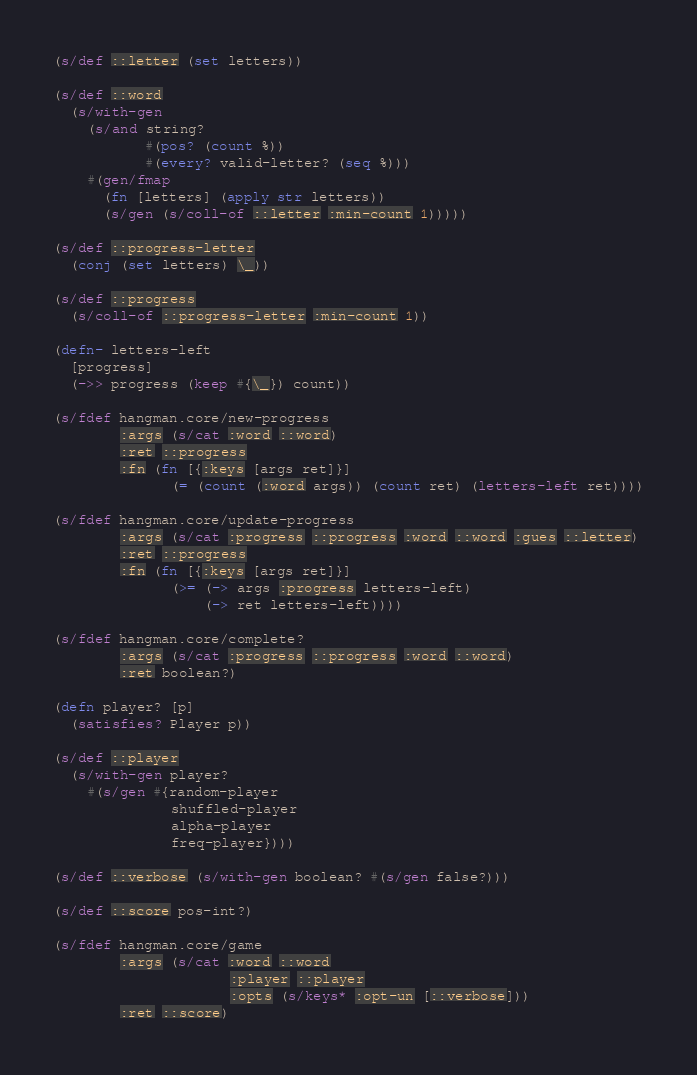Convert code to text. <code><loc_0><loc_0><loc_500><loc_500><_Clojure_>(s/def ::letter (set letters))

(s/def ::word
  (s/with-gen
    (s/and string?
           #(pos? (count %))
           #(every? valid-letter? (seq %)))
    #(gen/fmap
      (fn [letters] (apply str letters))
      (s/gen (s/coll-of ::letter :min-count 1)))))

(s/def ::progress-letter
  (conj (set letters) \_))

(s/def ::progress
  (s/coll-of ::progress-letter :min-count 1))

(defn- letters-left
  [progress]
  (->> progress (keep #{\_}) count))

(s/fdef hangman.core/new-progress
        :args (s/cat :word ::word)
        :ret ::progress
        :fn (fn [{:keys [args ret]}]
              (= (count (:word args)) (count ret) (letters-left ret))))

(s/fdef hangman.core/update-progress
        :args (s/cat :progress ::progress :word ::word :gues ::letter)
        :ret ::progress
        :fn (fn [{:keys [args ret]}]
              (>= (-> args :progress letters-left)
                  (-> ret letters-left))))

(s/fdef hangman.core/complete?
        :args (s/cat :progress ::progress :word ::word)
        :ret boolean?)

(defn player? [p]
  (satisfies? Player p))

(s/def ::player
  (s/with-gen player?
    #(s/gen #{random-player
              shuffled-player
              alpha-player
              freq-player})))

(s/def ::verbose (s/with-gen boolean? #(s/gen false?)))

(s/def ::score pos-int?)

(s/fdef hangman.core/game
        :args (s/cat :word ::word
                     :player ::player
                     :opts (s/keys* :opt-un [::verbose]))
        :ret ::score)
</code> 